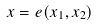Convert formula to latex. <formula><loc_0><loc_0><loc_500><loc_500>x = e ( x _ { 1 } , x _ { 2 } )</formula> 